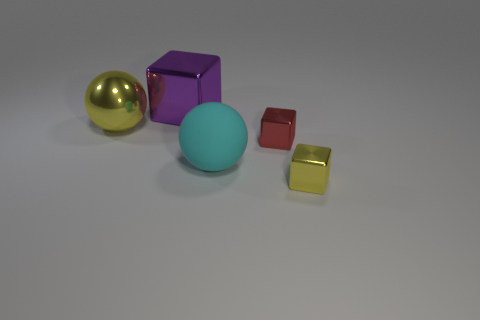Add 1 large blocks. How many objects exist? 6 Subtract all blocks. How many objects are left? 2 Subtract 0 blue blocks. How many objects are left? 5 Subtract all spheres. Subtract all yellow objects. How many objects are left? 1 Add 3 yellow metallic spheres. How many yellow metallic spheres are left? 4 Add 2 yellow metallic things. How many yellow metallic things exist? 4 